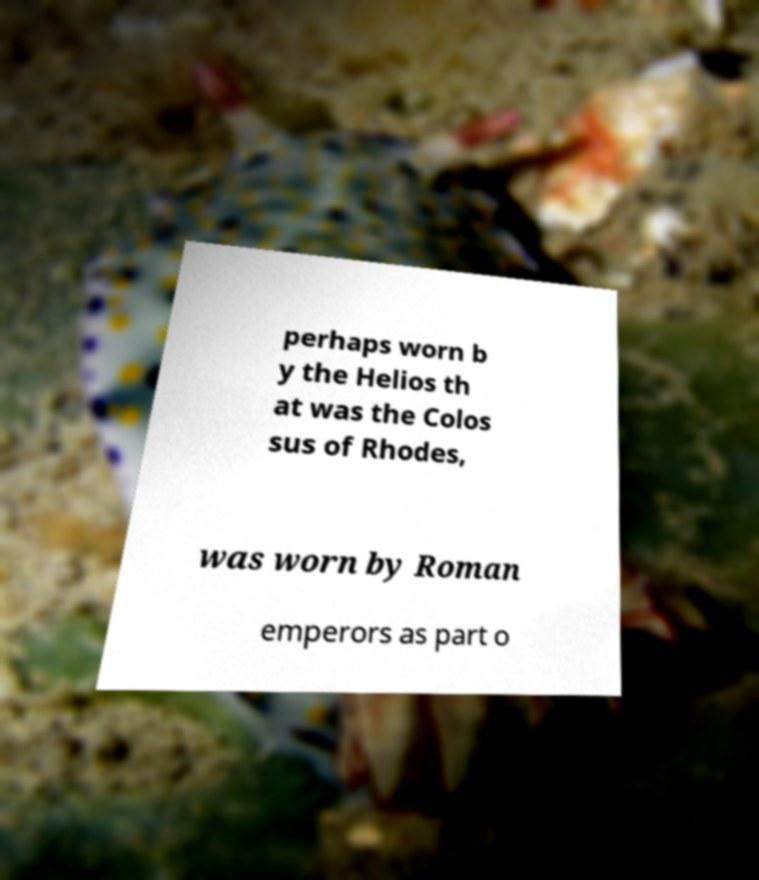Could you assist in decoding the text presented in this image and type it out clearly? perhaps worn b y the Helios th at was the Colos sus of Rhodes, was worn by Roman emperors as part o 